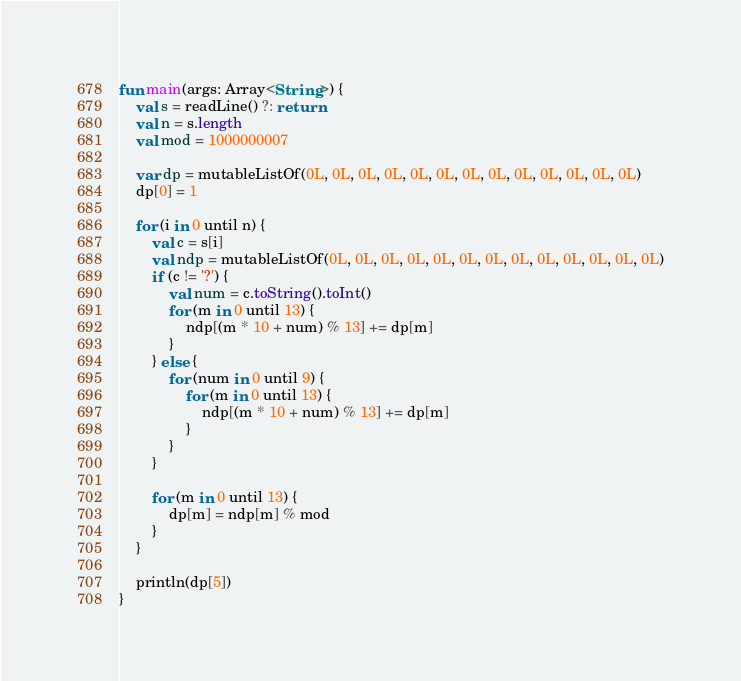<code> <loc_0><loc_0><loc_500><loc_500><_Kotlin_>fun main(args: Array<String>) {
    val s = readLine() ?: return
    val n = s.length
    val mod = 1000000007

    var dp = mutableListOf(0L, 0L, 0L, 0L, 0L, 0L, 0L, 0L, 0L, 0L, 0L, 0L, 0L)
    dp[0] = 1
  
    for (i in 0 until n) {
        val c = s[i]
        val ndp = mutableListOf(0L, 0L, 0L, 0L, 0L, 0L, 0L, 0L, 0L, 0L, 0L, 0L, 0L)
        if (c != '?') {
            val num = c.toString().toInt()
            for (m in 0 until 13) {
                ndp[(m * 10 + num) % 13] += dp[m]
            }
        } else {
            for (num in 0 until 9) {
                for (m in 0 until 13) {
                    ndp[(m * 10 + num) % 13] += dp[m]
                }
            }
        }

        for (m in 0 until 13) {
            dp[m] = ndp[m] % mod
        }
    }

    println(dp[5])
}</code> 